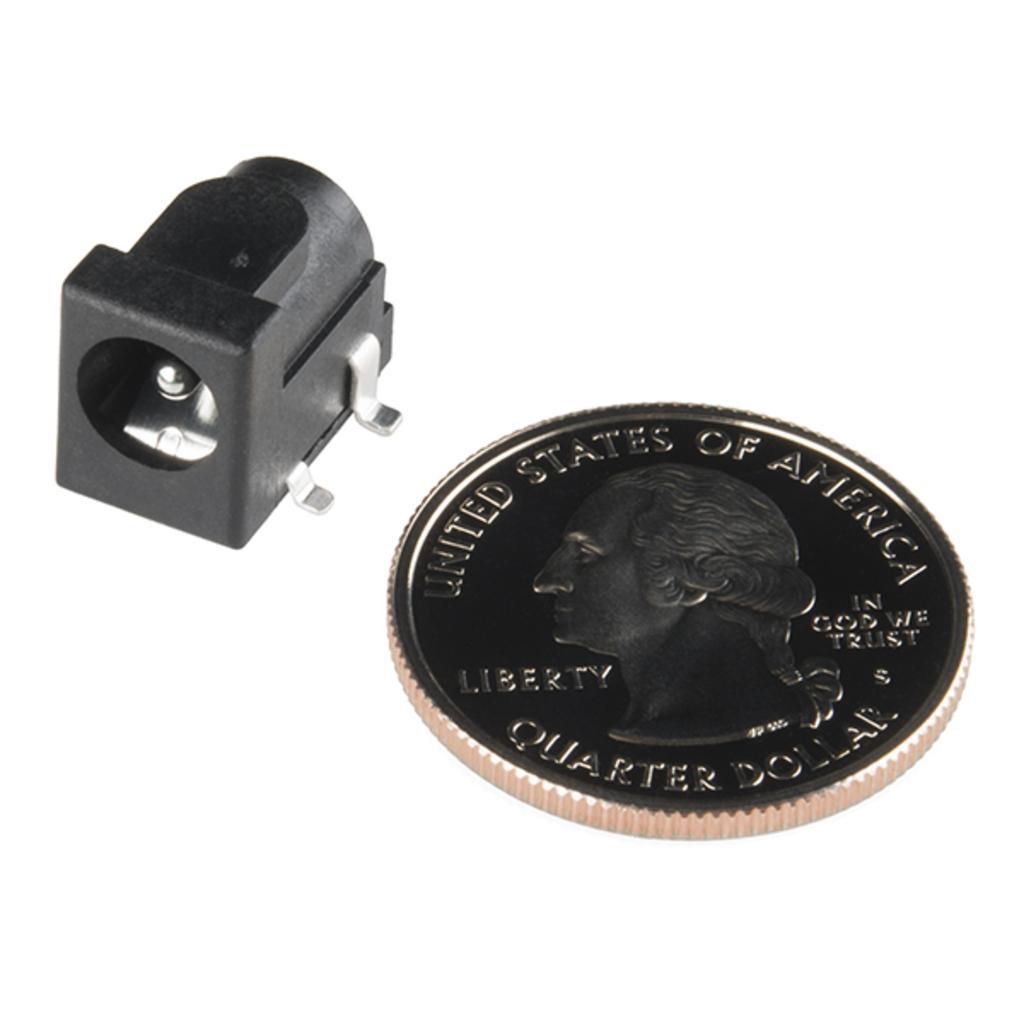How would you summarize this image in a sentence or two? In this image, we can see a coin and an object. 